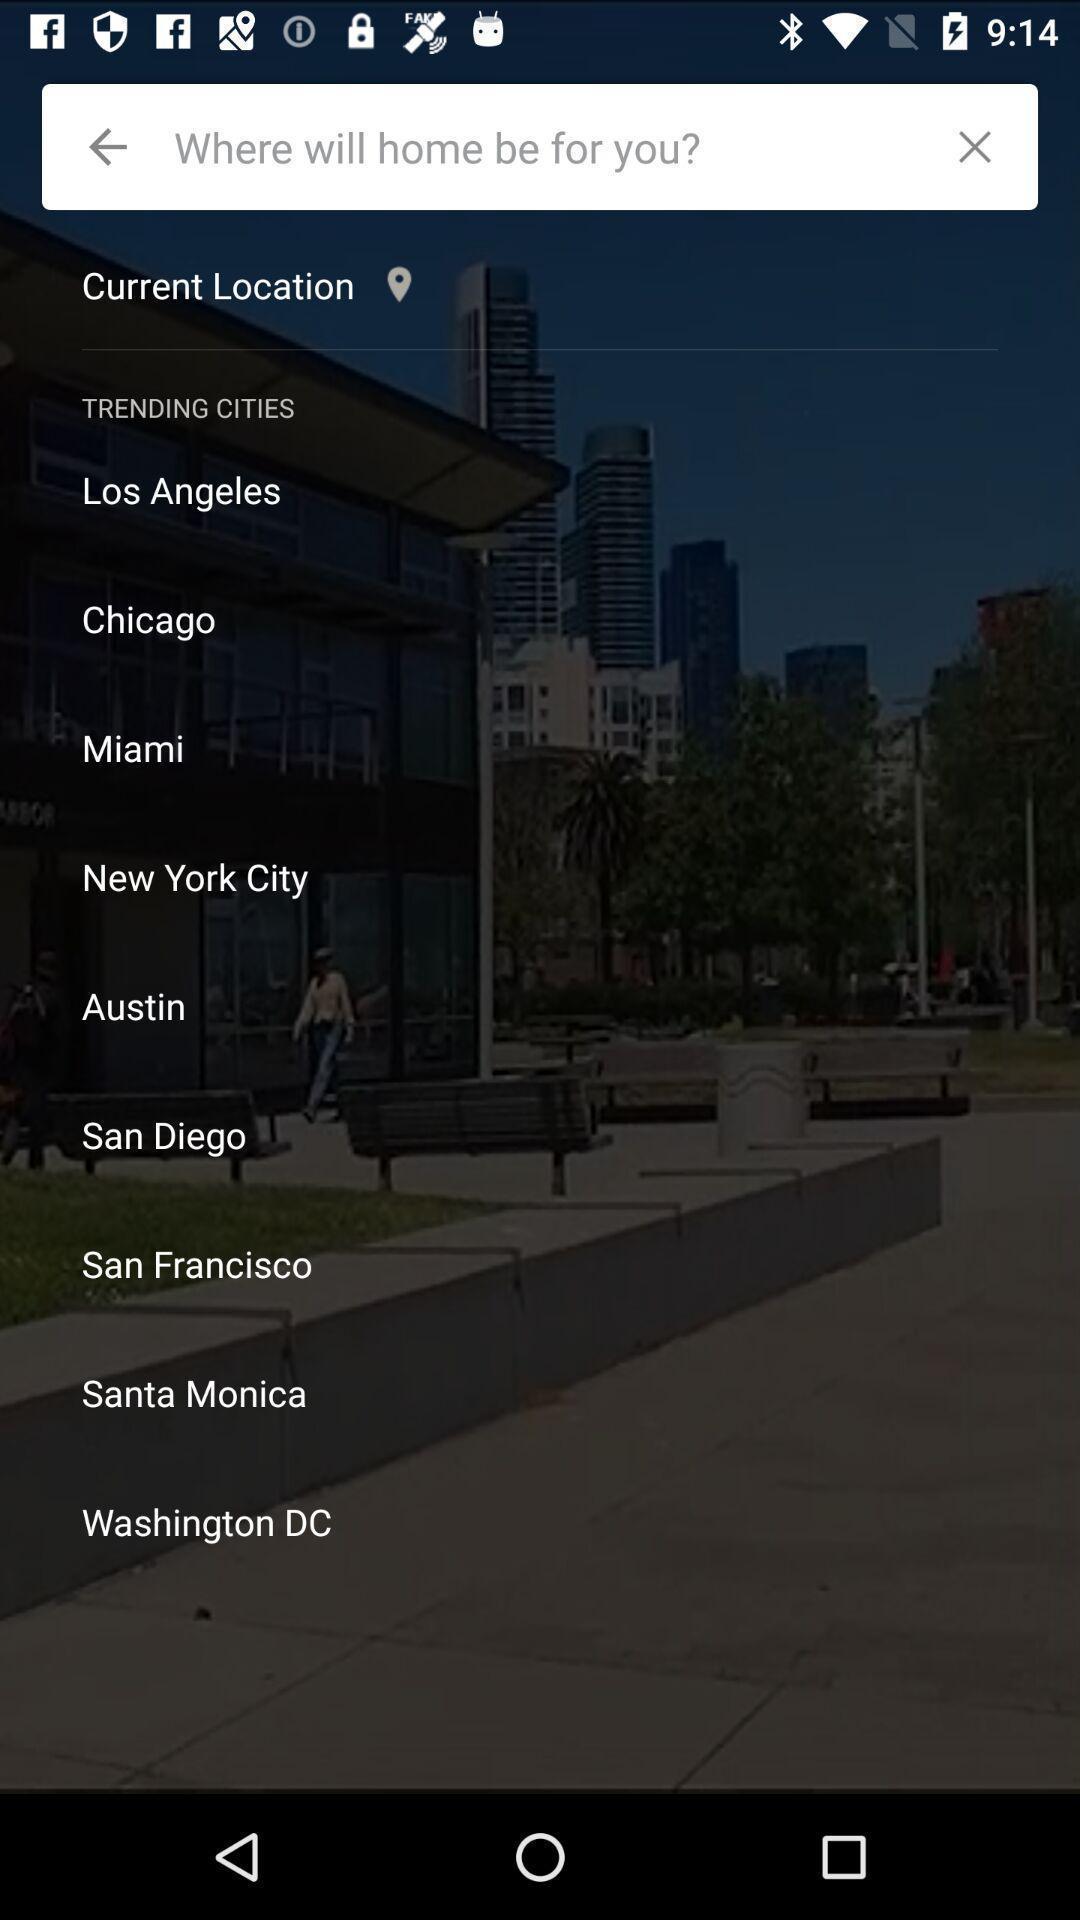Provide a detailed account of this screenshot. Screen displaying the list of locations. 